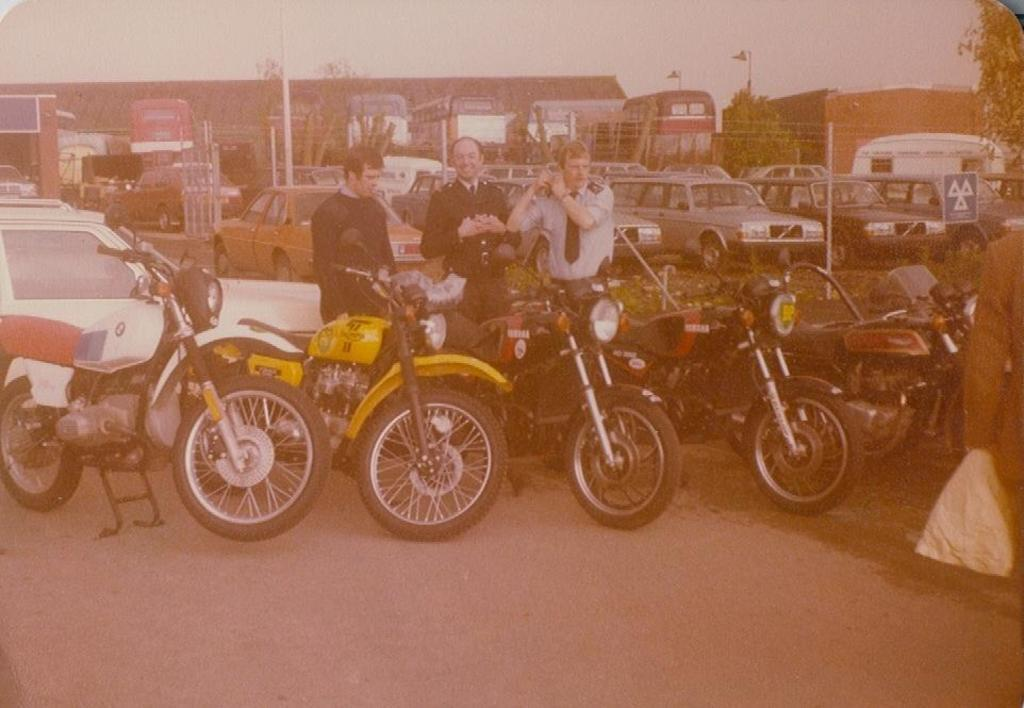What type of vehicles can be seen in the image? There are motorcycles in the image. Are there any other types of vehicles besides motorcycles? A: Yes, there are other vehicles in the image. What else can be seen in the image besides vehicles? There are people standing in the image. What is visible in the background of the image? There are trees and buildings in the background of the image. What is visible at the top of the image? The sky is visible in the image. Can you see a cherry on top of the motorcycle in the image? There is no cherry present on top of the motorcycle or any other vehicle in the image. 